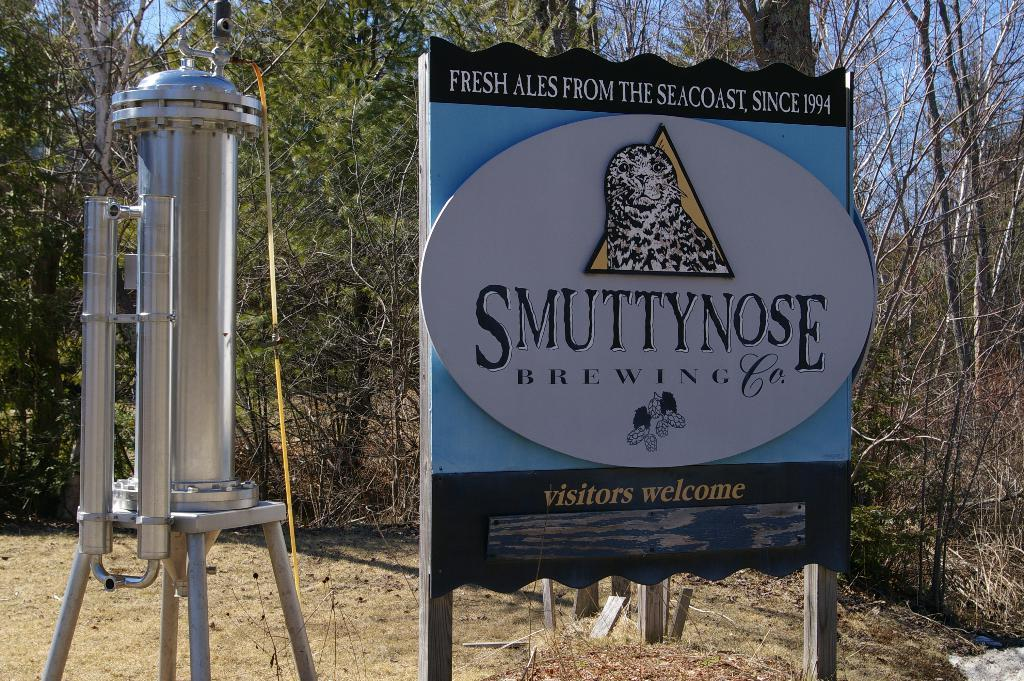What is the main object in the image? There is a board in the image. What is the board resting on? The board is on wooden objects. What type of object can be seen on the left side of the image? There is a steel object on the left side of the image. What can be seen in the background of the image? There are trees in the background of the image. How many eggs are visible on the board in the image? There are no eggs present in the image. What type of sugar is being used to sweeten the board in the image? There is no sugar present in the image, and the board is not being sweetened. 